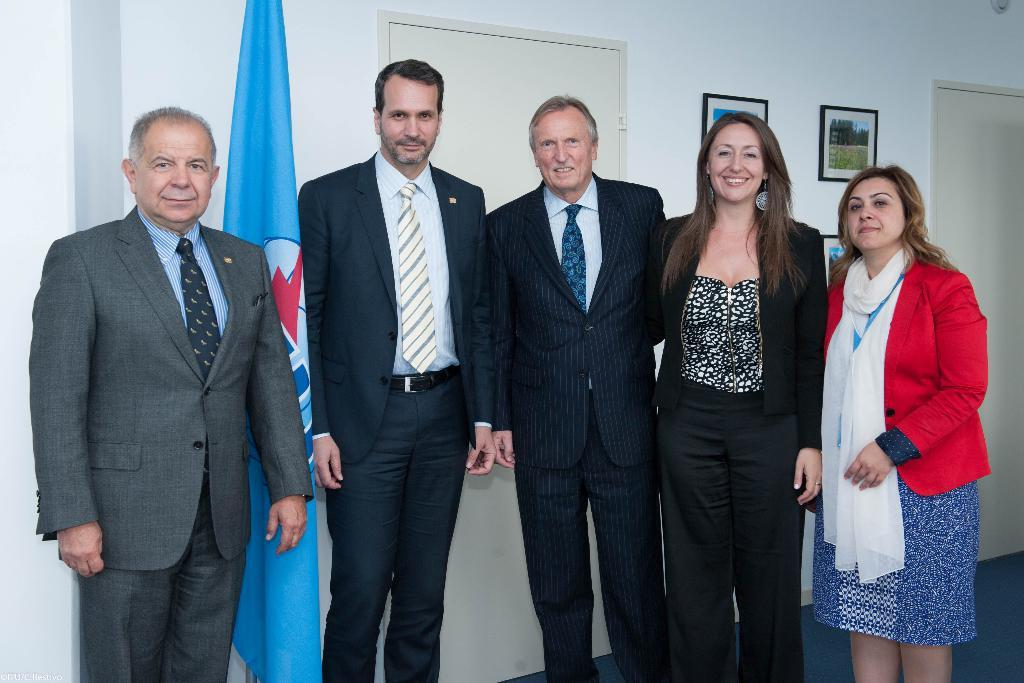What are the people in the image doing? The people in the image are standing and smiling. What can be seen in the background of the image? There are doors visible in the image. What is the decoration on the wall in the image? There are photo frames on the wall in the image. What symbol or emblem is present in the image? There is a flag in the image. What type of soda is being served in the image? There is no soda present in the image. What book is the person reading in the image? There is no person reading a book in the image. Is there a bomb visible in the image? No, there is no bomb present in the image. 